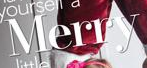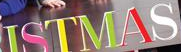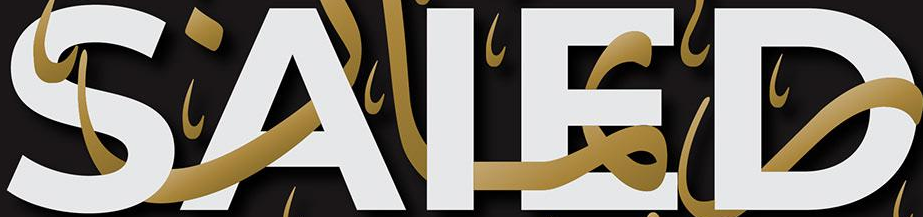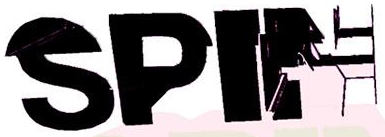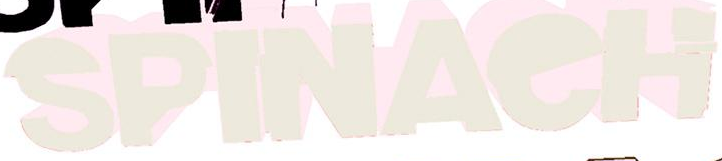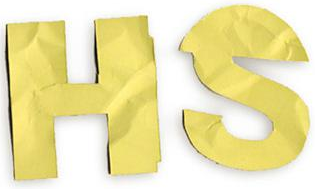What words can you see in these images in sequence, separated by a semicolon? Merry; ISTMAS; SAIED; SPIN; SPINAeH; HS 